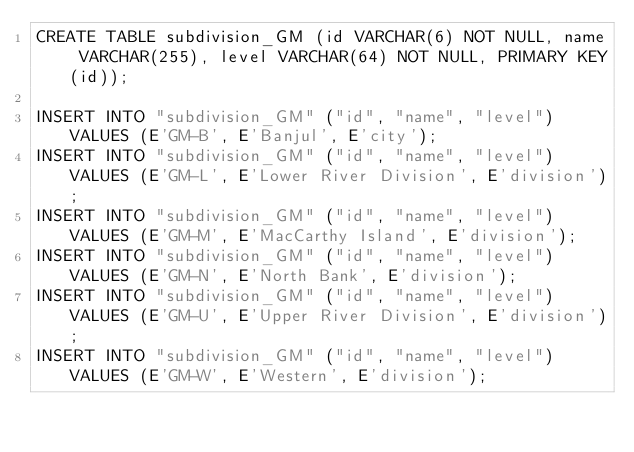<code> <loc_0><loc_0><loc_500><loc_500><_SQL_>CREATE TABLE subdivision_GM (id VARCHAR(6) NOT NULL, name VARCHAR(255), level VARCHAR(64) NOT NULL, PRIMARY KEY(id));

INSERT INTO "subdivision_GM" ("id", "name", "level") VALUES (E'GM-B', E'Banjul', E'city');
INSERT INTO "subdivision_GM" ("id", "name", "level") VALUES (E'GM-L', E'Lower River Division', E'division');
INSERT INTO "subdivision_GM" ("id", "name", "level") VALUES (E'GM-M', E'MacCarthy Island', E'division');
INSERT INTO "subdivision_GM" ("id", "name", "level") VALUES (E'GM-N', E'North Bank', E'division');
INSERT INTO "subdivision_GM" ("id", "name", "level") VALUES (E'GM-U', E'Upper River Division', E'division');
INSERT INTO "subdivision_GM" ("id", "name", "level") VALUES (E'GM-W', E'Western', E'division');
</code> 